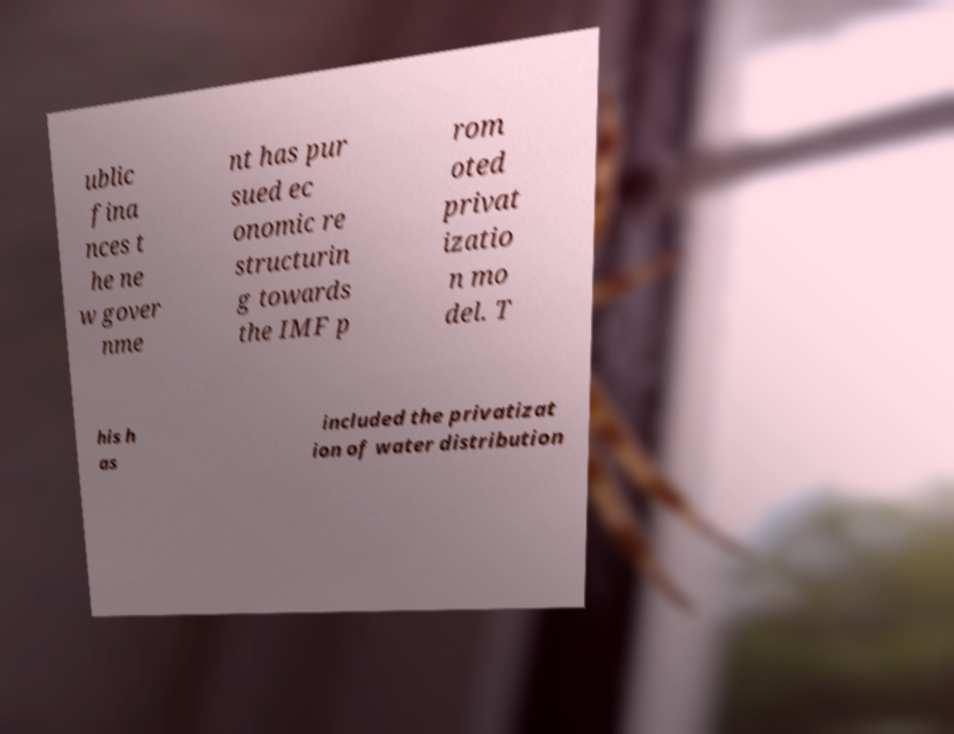What messages or text are displayed in this image? I need them in a readable, typed format. ublic fina nces t he ne w gover nme nt has pur sued ec onomic re structurin g towards the IMF p rom oted privat izatio n mo del. T his h as included the privatizat ion of water distribution 